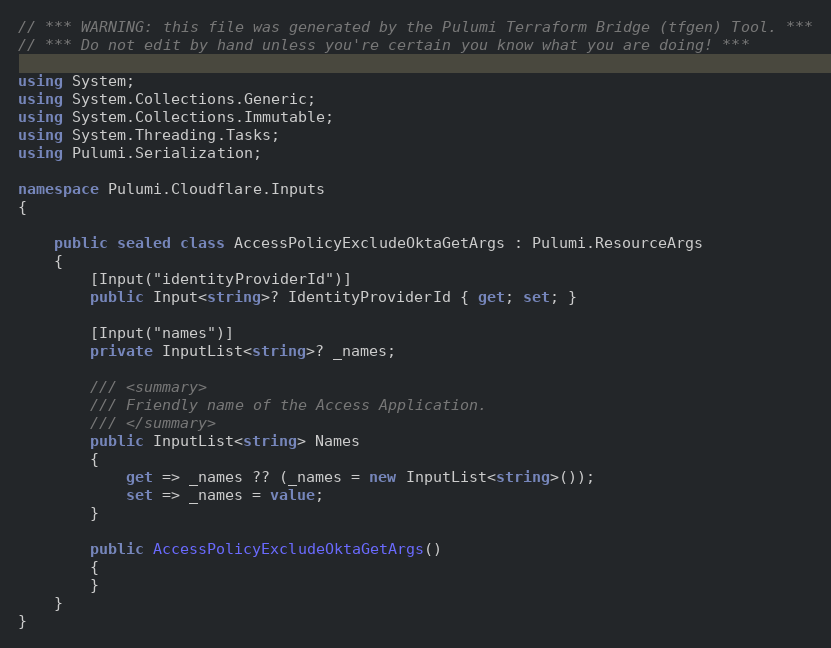<code> <loc_0><loc_0><loc_500><loc_500><_C#_>// *** WARNING: this file was generated by the Pulumi Terraform Bridge (tfgen) Tool. ***
// *** Do not edit by hand unless you're certain you know what you are doing! ***

using System;
using System.Collections.Generic;
using System.Collections.Immutable;
using System.Threading.Tasks;
using Pulumi.Serialization;

namespace Pulumi.Cloudflare.Inputs
{

    public sealed class AccessPolicyExcludeOktaGetArgs : Pulumi.ResourceArgs
    {
        [Input("identityProviderId")]
        public Input<string>? IdentityProviderId { get; set; }

        [Input("names")]
        private InputList<string>? _names;

        /// <summary>
        /// Friendly name of the Access Application.
        /// </summary>
        public InputList<string> Names
        {
            get => _names ?? (_names = new InputList<string>());
            set => _names = value;
        }

        public AccessPolicyExcludeOktaGetArgs()
        {
        }
    }
}
</code> 